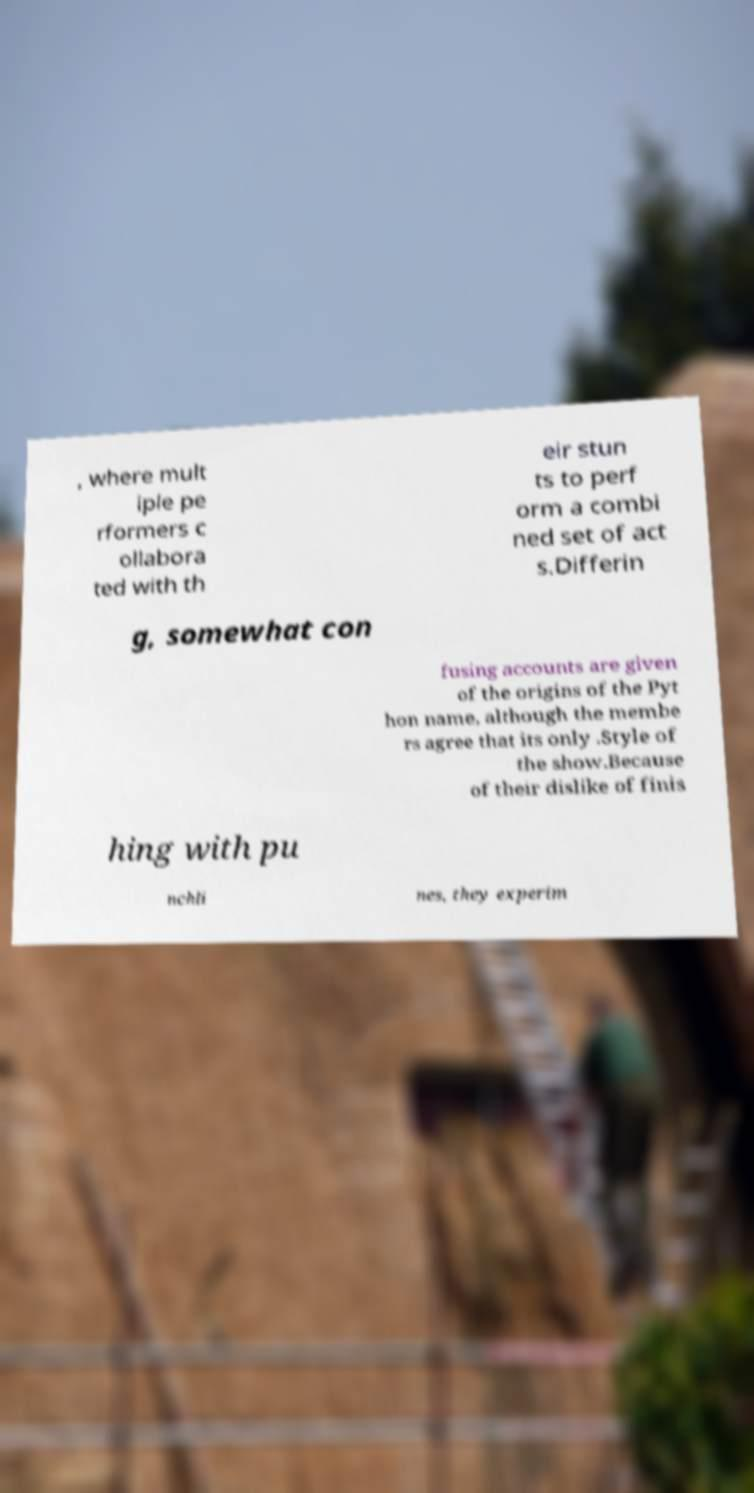Could you extract and type out the text from this image? , where mult iple pe rformers c ollabora ted with th eir stun ts to perf orm a combi ned set of act s.Differin g, somewhat con fusing accounts are given of the origins of the Pyt hon name, although the membe rs agree that its only .Style of the show.Because of their dislike of finis hing with pu nchli nes, they experim 